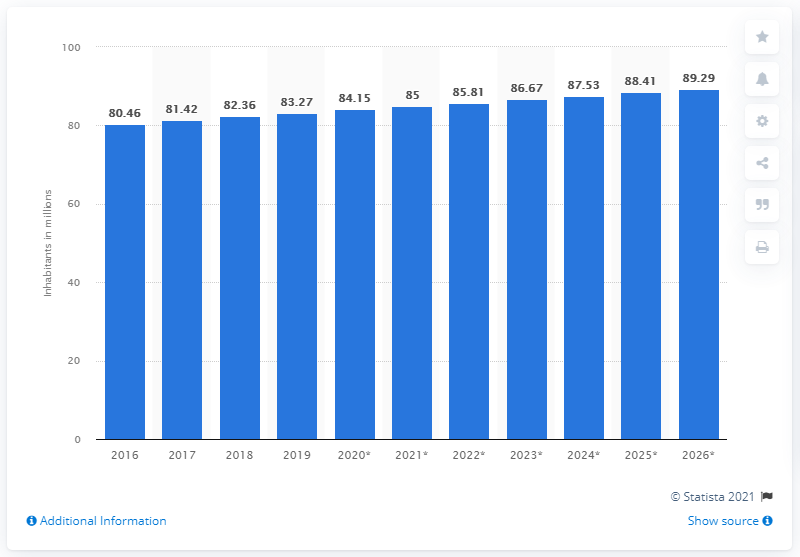Indicate a few pertinent items in this graphic. In 2019, the population of Iran was 83.27 million. In 2016, the total population of Iran was. 